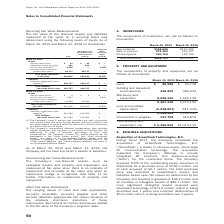From Qorvo's financial document, What are the respective values of the company's raw materials on March 31, 2018 and 2019? The document shows two values: $110,389 and $118,608 (in thousands). From the document: "Raw materials $118,608 $110,389 Work in process 272,469 221,137 Finished goods 120,716 140,766 Raw materials $118,608 $110,389 Work in process 272,469..." Also, What are the respective values of the company's work in process inventories on March 31, 2018 and 2019? The document shows two values: 221,137 and 272,469 (in thousands). From the document: "Raw materials $118,608 $110,389 Work in process 272,469 221,137 Finished goods 120,716 140,766 terials $118,608 $110,389 Work in process 272,469 221,1..." Also, What are the respective values of the company's finished goods on March 31, 2018 and 2019? The document shows two values: 140,766 and 120,716 (in thousands). From the document: "89 Work in process 272,469 221,137 Finished goods 120,716 140,766 in process 272,469 221,137 Finished goods 120,716 140,766..." Also, can you calculate: What is the change in the company's raw materials on March 31, 2018 and 2019? Based on the calculation: $118,608 - $110,389 , the result is 8219 (in thousands). This is based on the information: "Raw materials $118,608 $110,389 Work in process 272,469 221,137 Finished goods 120,716 140,766 Raw materials $118,608 $110,389 Work in process 272,469 221,137 Finished goods 120,716 140,766..." The key data points involved are: 110,389, 118,608. Also, can you calculate: What is the average value of the company's raw materials on March 31, 2018 and 2019? To answer this question, I need to perform calculations using the financial data. The calculation is: ($110,389 + $118,608)/2 , which equals 114498.5 (in thousands). This is based on the information: "Raw materials $118,608 $110,389 Work in process 272,469 221,137 Finished goods 120,716 140,766 Raw materials $118,608 $110,389 Work in process 272,469 221,137 Finished goods 120,716 140,766..." The key data points involved are: 110,389, 118,608. Also, can you calculate: What is the average value of the company's finished goods on March 31, 2018 and 2019? To answer this question, I need to perform calculations using the financial data. The calculation is: (140,766 + 120,716)/2 , which equals 130741 (in thousands). This is based on the information: "89 Work in process 272,469 221,137 Finished goods 120,716 140,766 in process 272,469 221,137 Finished goods 120,716 140,766..." The key data points involved are: 120,716, 140,766. 